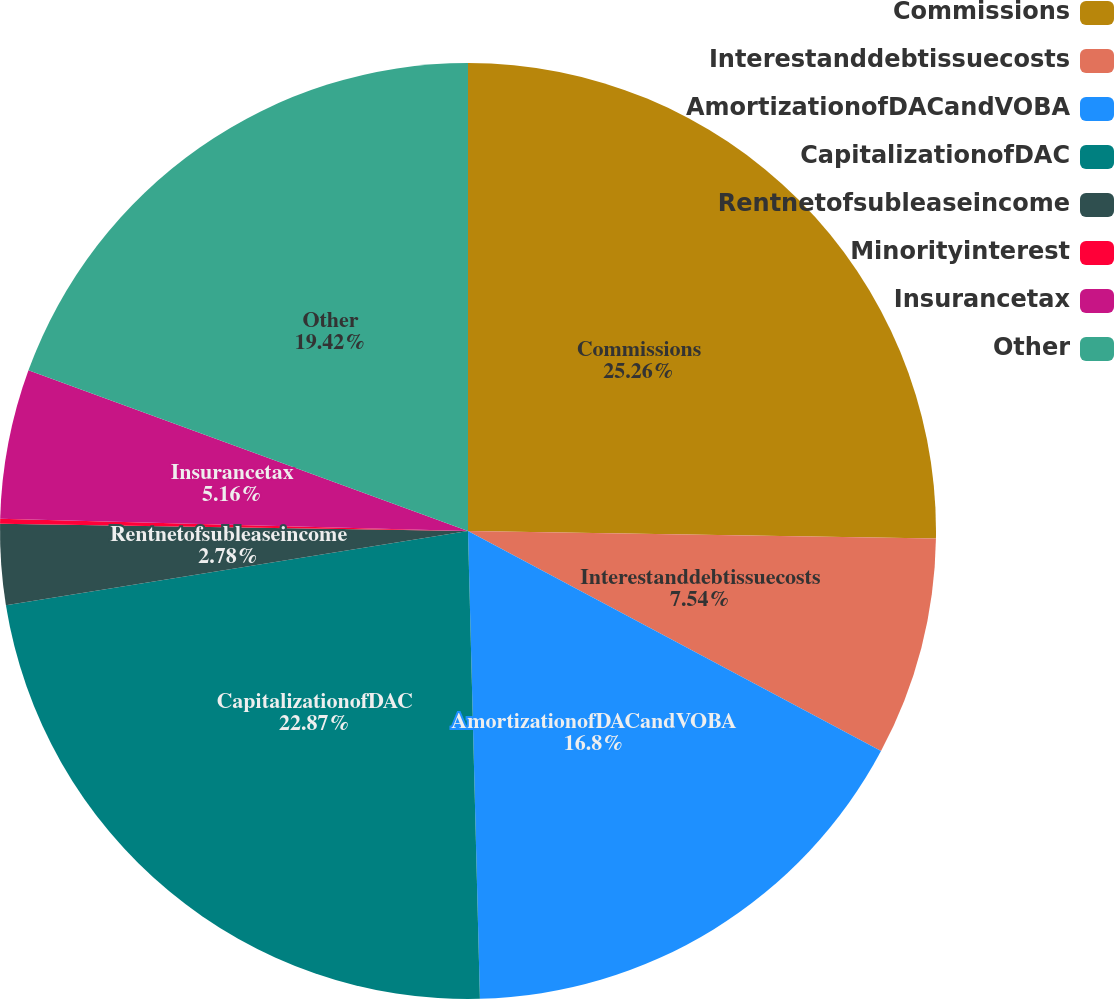Convert chart to OTSL. <chart><loc_0><loc_0><loc_500><loc_500><pie_chart><fcel>Commissions<fcel>Interestanddebtissuecosts<fcel>AmortizationofDACandVOBA<fcel>CapitalizationofDAC<fcel>Rentnetofsubleaseincome<fcel>Minorityinterest<fcel>Insurancetax<fcel>Other<nl><fcel>25.25%<fcel>7.54%<fcel>16.8%<fcel>22.87%<fcel>2.78%<fcel>0.17%<fcel>5.16%<fcel>19.42%<nl></chart> 